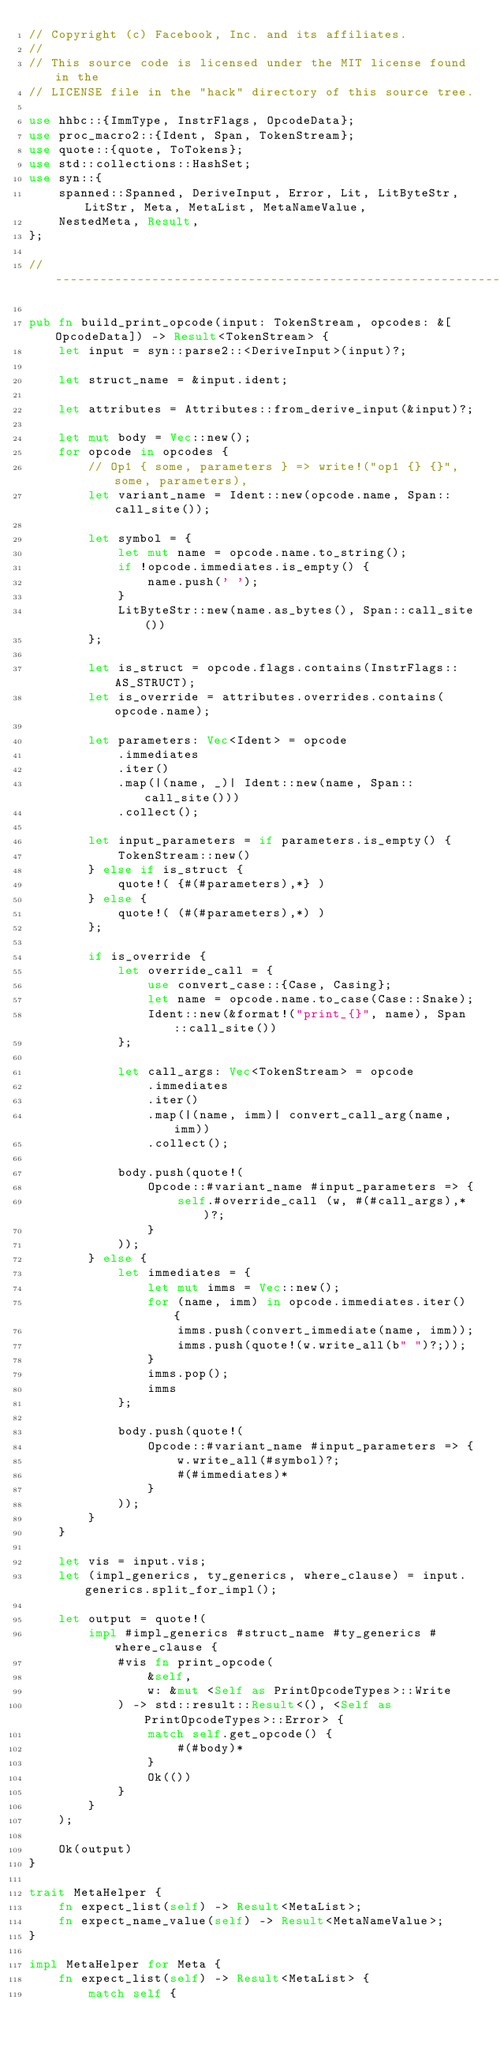<code> <loc_0><loc_0><loc_500><loc_500><_Rust_>// Copyright (c) Facebook, Inc. and its affiliates.
//
// This source code is licensed under the MIT license found in the
// LICENSE file in the "hack" directory of this source tree.

use hhbc::{ImmType, InstrFlags, OpcodeData};
use proc_macro2::{Ident, Span, TokenStream};
use quote::{quote, ToTokens};
use std::collections::HashSet;
use syn::{
    spanned::Spanned, DeriveInput, Error, Lit, LitByteStr, LitStr, Meta, MetaList, MetaNameValue,
    NestedMeta, Result,
};

// ----------------------------------------------------------------------------

pub fn build_print_opcode(input: TokenStream, opcodes: &[OpcodeData]) -> Result<TokenStream> {
    let input = syn::parse2::<DeriveInput>(input)?;

    let struct_name = &input.ident;

    let attributes = Attributes::from_derive_input(&input)?;

    let mut body = Vec::new();
    for opcode in opcodes {
        // Op1 { some, parameters } => write!("op1 {} {}", some, parameters),
        let variant_name = Ident::new(opcode.name, Span::call_site());

        let symbol = {
            let mut name = opcode.name.to_string();
            if !opcode.immediates.is_empty() {
                name.push(' ');
            }
            LitByteStr::new(name.as_bytes(), Span::call_site())
        };

        let is_struct = opcode.flags.contains(InstrFlags::AS_STRUCT);
        let is_override = attributes.overrides.contains(opcode.name);

        let parameters: Vec<Ident> = opcode
            .immediates
            .iter()
            .map(|(name, _)| Ident::new(name, Span::call_site()))
            .collect();

        let input_parameters = if parameters.is_empty() {
            TokenStream::new()
        } else if is_struct {
            quote!( {#(#parameters),*} )
        } else {
            quote!( (#(#parameters),*) )
        };

        if is_override {
            let override_call = {
                use convert_case::{Case, Casing};
                let name = opcode.name.to_case(Case::Snake);
                Ident::new(&format!("print_{}", name), Span::call_site())
            };

            let call_args: Vec<TokenStream> = opcode
                .immediates
                .iter()
                .map(|(name, imm)| convert_call_arg(name, imm))
                .collect();

            body.push(quote!(
                Opcode::#variant_name #input_parameters => {
                    self.#override_call (w, #(#call_args),* )?;
                }
            ));
        } else {
            let immediates = {
                let mut imms = Vec::new();
                for (name, imm) in opcode.immediates.iter() {
                    imms.push(convert_immediate(name, imm));
                    imms.push(quote!(w.write_all(b" ")?;));
                }
                imms.pop();
                imms
            };

            body.push(quote!(
                Opcode::#variant_name #input_parameters => {
                    w.write_all(#symbol)?;
                    #(#immediates)*
                }
            ));
        }
    }

    let vis = input.vis;
    let (impl_generics, ty_generics, where_clause) = input.generics.split_for_impl();

    let output = quote!(
        impl #impl_generics #struct_name #ty_generics #where_clause {
            #vis fn print_opcode(
                &self,
                w: &mut <Self as PrintOpcodeTypes>::Write
            ) -> std::result::Result<(), <Self as PrintOpcodeTypes>::Error> {
                match self.get_opcode() {
                    #(#body)*
                }
                Ok(())
            }
        }
    );

    Ok(output)
}

trait MetaHelper {
    fn expect_list(self) -> Result<MetaList>;
    fn expect_name_value(self) -> Result<MetaNameValue>;
}

impl MetaHelper for Meta {
    fn expect_list(self) -> Result<MetaList> {
        match self {</code> 